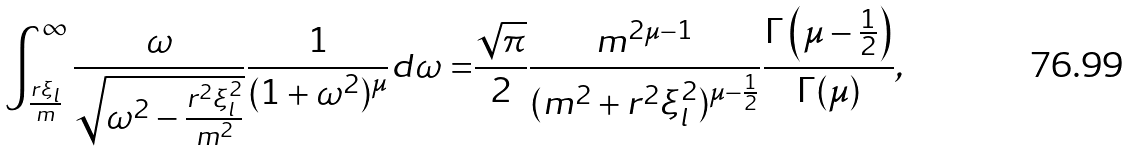<formula> <loc_0><loc_0><loc_500><loc_500>\int _ { \frac { r \xi _ { l } } { m } } ^ { \infty } \frac { \omega } { \sqrt { \omega ^ { 2 } - \frac { r ^ { 2 } \xi _ { l } ^ { 2 } } { m ^ { 2 } } } } \frac { 1 } { ( 1 + \omega ^ { 2 } ) ^ { \mu } } d \omega = & \frac { \sqrt { \pi } } { 2 } \frac { m ^ { 2 \mu - 1 } } { ( m ^ { 2 } + r ^ { 2 } \xi _ { l } ^ { 2 } ) ^ { \mu - \frac { 1 } { 2 } } } \frac { \Gamma \left ( \mu - \frac { 1 } { 2 } \right ) } { \Gamma ( \mu ) } ,</formula> 